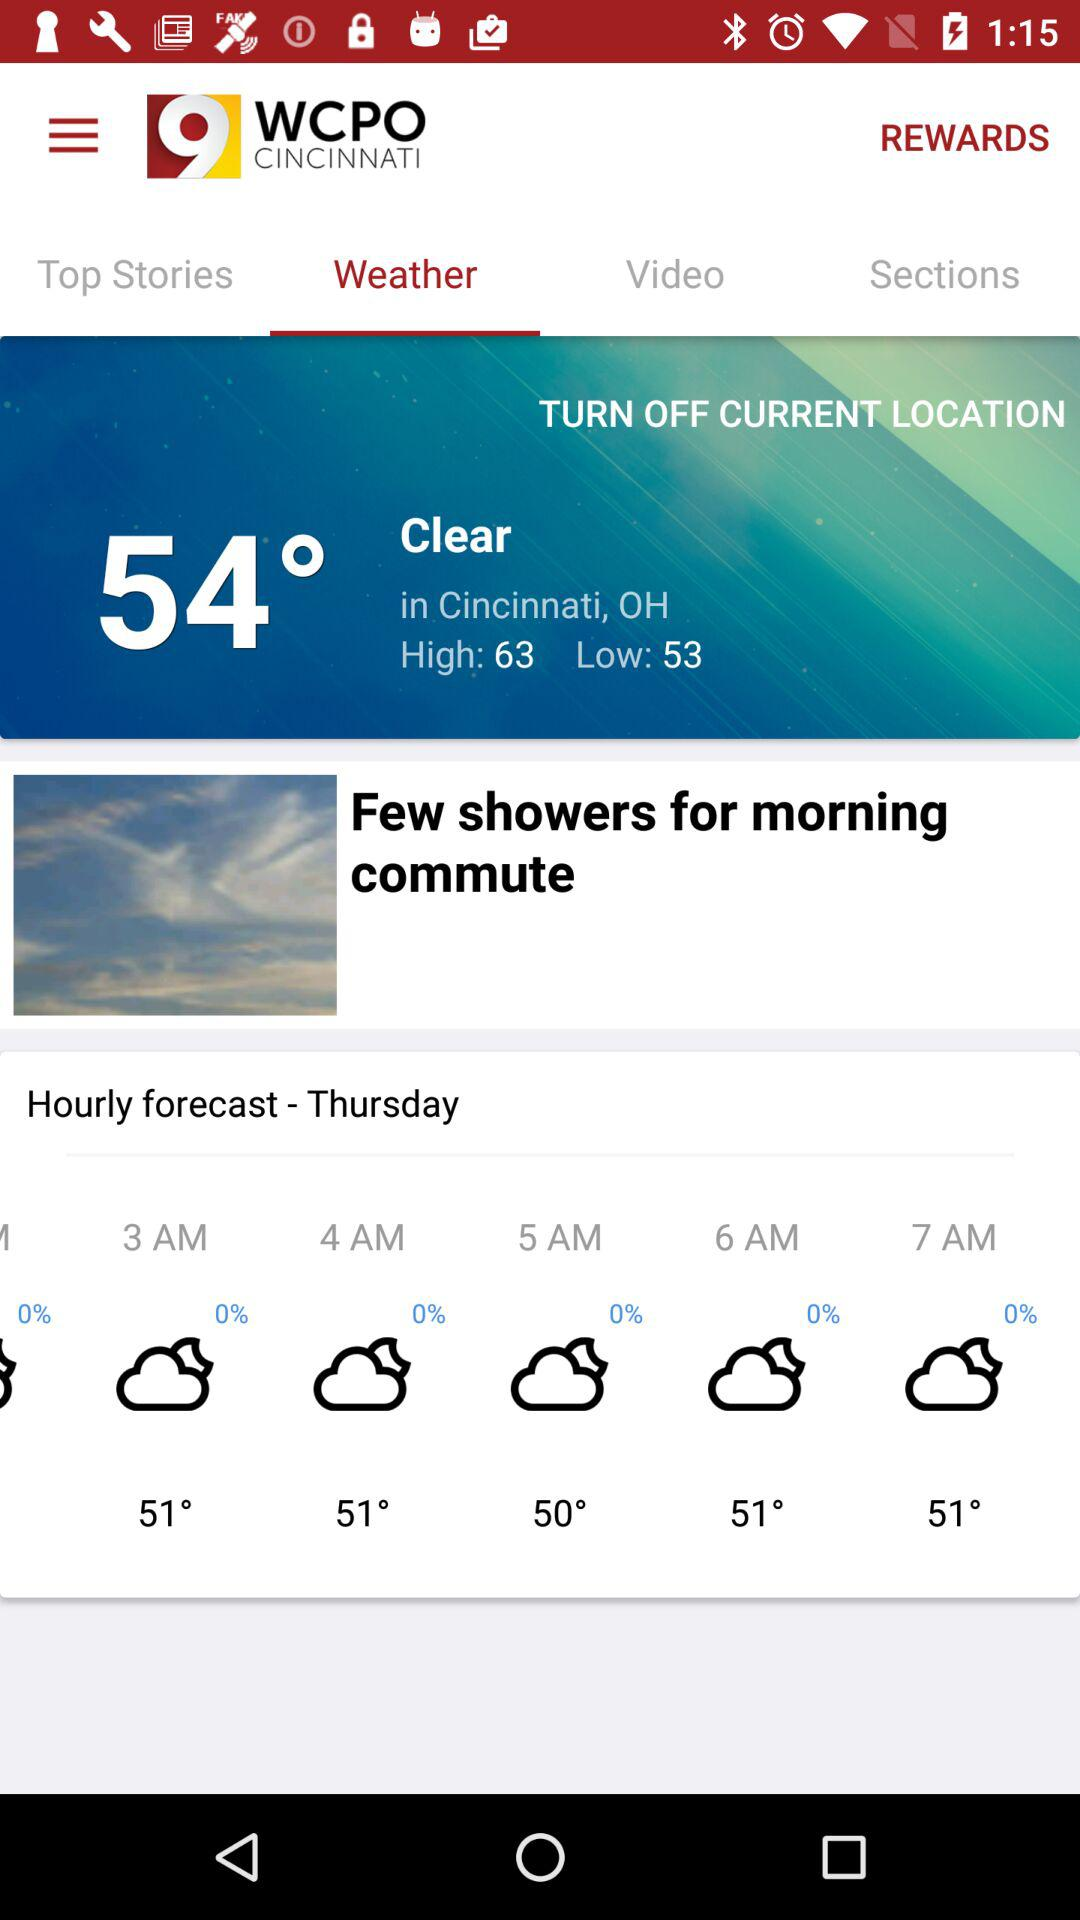What will be the expected high temperature? The expected high temperature will be 63 degrees. 